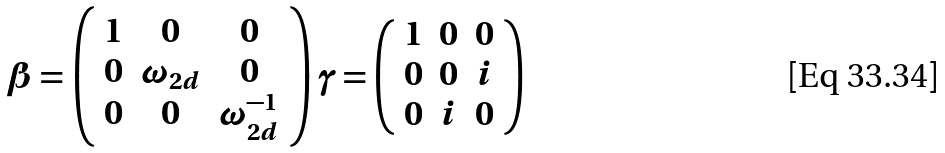Convert formula to latex. <formula><loc_0><loc_0><loc_500><loc_500>\beta = \left ( \begin{array} { c c c } 1 & 0 & 0 \\ 0 & \omega _ { 2 d } & 0 \\ 0 & 0 & \omega _ { 2 d } ^ { - 1 } \end{array} \right ) \gamma = \left ( \begin{array} { c c c } 1 & 0 & 0 \\ 0 & 0 & i \\ 0 & i & 0 \end{array} \right )</formula> 